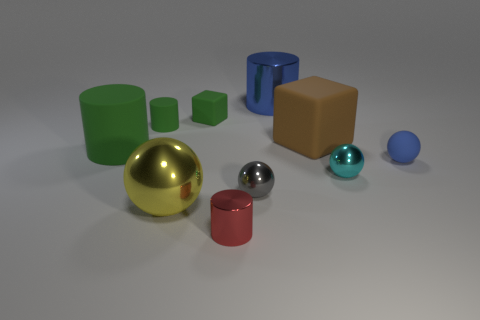Can you tell me which objects in the picture are reflective? Certainly, the objects that display reflective properties in this image include the golden ball, the silver ball, and the small, shiny blue ball. The surface of these spheres reflects the environment, which indicates their shiny, metallic materials. Which one is the most reflective? Among them, the golden ball seems to be the most reflective. It has a high-gloss finish that provides a clear mirror-like reflection of its surroundings. 